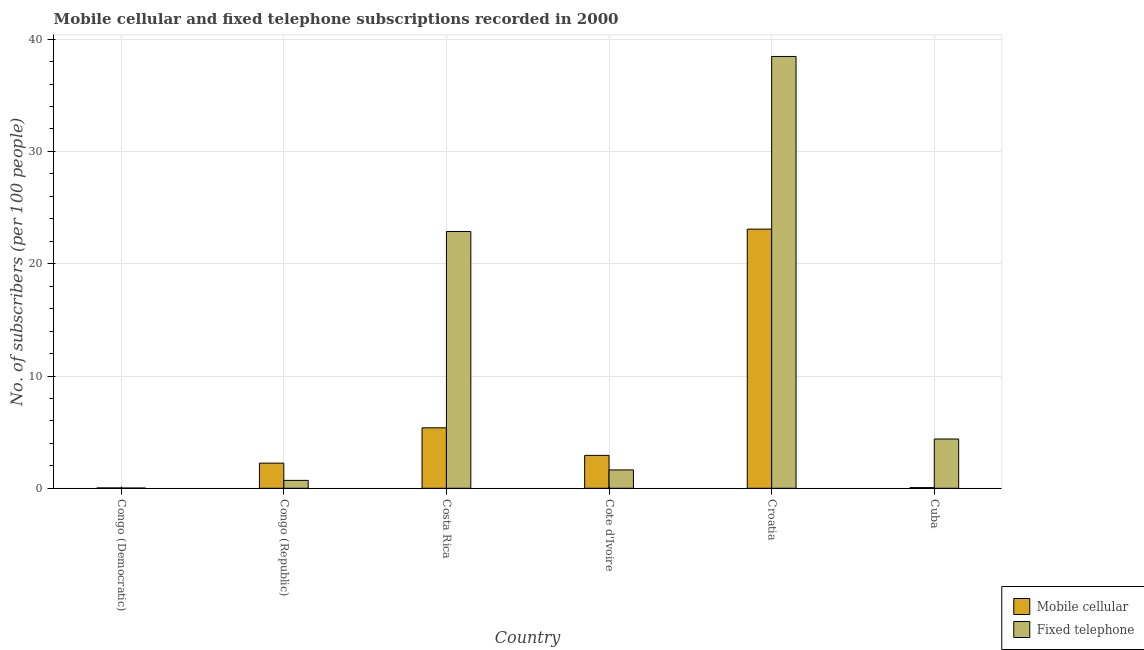Are the number of bars per tick equal to the number of legend labels?
Keep it short and to the point. Yes. How many bars are there on the 1st tick from the left?
Your response must be concise. 2. What is the label of the 1st group of bars from the left?
Your answer should be compact. Congo (Democratic). What is the number of fixed telephone subscribers in Congo (Republic)?
Keep it short and to the point. 0.7. Across all countries, what is the maximum number of fixed telephone subscribers?
Your answer should be compact. 38.46. Across all countries, what is the minimum number of mobile cellular subscribers?
Offer a terse response. 0.03. In which country was the number of mobile cellular subscribers maximum?
Your response must be concise. Croatia. In which country was the number of fixed telephone subscribers minimum?
Your answer should be very brief. Congo (Democratic). What is the total number of mobile cellular subscribers in the graph?
Provide a succinct answer. 33.73. What is the difference between the number of fixed telephone subscribers in Congo (Republic) and that in Croatia?
Ensure brevity in your answer.  -37.76. What is the difference between the number of mobile cellular subscribers in Costa Rica and the number of fixed telephone subscribers in Cote d'Ivoire?
Give a very brief answer. 3.75. What is the average number of mobile cellular subscribers per country?
Make the answer very short. 5.62. What is the difference between the number of mobile cellular subscribers and number of fixed telephone subscribers in Congo (Democratic)?
Keep it short and to the point. 0.01. In how many countries, is the number of fixed telephone subscribers greater than 10 ?
Your answer should be very brief. 2. What is the ratio of the number of mobile cellular subscribers in Congo (Democratic) to that in Cuba?
Your answer should be compact. 0.54. Is the difference between the number of mobile cellular subscribers in Costa Rica and Cuba greater than the difference between the number of fixed telephone subscribers in Costa Rica and Cuba?
Offer a very short reply. No. What is the difference between the highest and the second highest number of mobile cellular subscribers?
Give a very brief answer. 17.7. What is the difference between the highest and the lowest number of mobile cellular subscribers?
Provide a succinct answer. 23.05. What does the 1st bar from the left in Cote d'Ivoire represents?
Give a very brief answer. Mobile cellular. What does the 1st bar from the right in Croatia represents?
Make the answer very short. Fixed telephone. What is the difference between two consecutive major ticks on the Y-axis?
Offer a very short reply. 10. Are the values on the major ticks of Y-axis written in scientific E-notation?
Your response must be concise. No. Does the graph contain any zero values?
Your answer should be compact. No. Where does the legend appear in the graph?
Keep it short and to the point. Bottom right. How many legend labels are there?
Make the answer very short. 2. What is the title of the graph?
Your answer should be compact. Mobile cellular and fixed telephone subscriptions recorded in 2000. Does "Lower secondary rate" appear as one of the legend labels in the graph?
Offer a terse response. No. What is the label or title of the X-axis?
Your answer should be compact. Country. What is the label or title of the Y-axis?
Ensure brevity in your answer.  No. of subscribers (per 100 people). What is the No. of subscribers (per 100 people) of Mobile cellular in Congo (Democratic)?
Your answer should be compact. 0.03. What is the No. of subscribers (per 100 people) of Fixed telephone in Congo (Democratic)?
Provide a short and direct response. 0.02. What is the No. of subscribers (per 100 people) of Mobile cellular in Congo (Republic)?
Provide a short and direct response. 2.24. What is the No. of subscribers (per 100 people) in Fixed telephone in Congo (Republic)?
Your response must be concise. 0.7. What is the No. of subscribers (per 100 people) of Mobile cellular in Costa Rica?
Your answer should be very brief. 5.39. What is the No. of subscribers (per 100 people) in Fixed telephone in Costa Rica?
Your response must be concise. 22.87. What is the No. of subscribers (per 100 people) of Mobile cellular in Cote d'Ivoire?
Make the answer very short. 2.93. What is the No. of subscribers (per 100 people) in Fixed telephone in Cote d'Ivoire?
Make the answer very short. 1.63. What is the No. of subscribers (per 100 people) of Mobile cellular in Croatia?
Your answer should be compact. 23.08. What is the No. of subscribers (per 100 people) of Fixed telephone in Croatia?
Offer a very short reply. 38.46. What is the No. of subscribers (per 100 people) of Mobile cellular in Cuba?
Make the answer very short. 0.06. What is the No. of subscribers (per 100 people) of Fixed telephone in Cuba?
Your answer should be compact. 4.39. Across all countries, what is the maximum No. of subscribers (per 100 people) of Mobile cellular?
Your answer should be compact. 23.08. Across all countries, what is the maximum No. of subscribers (per 100 people) in Fixed telephone?
Keep it short and to the point. 38.46. Across all countries, what is the minimum No. of subscribers (per 100 people) in Mobile cellular?
Your answer should be very brief. 0.03. Across all countries, what is the minimum No. of subscribers (per 100 people) of Fixed telephone?
Offer a very short reply. 0.02. What is the total No. of subscribers (per 100 people) in Mobile cellular in the graph?
Your response must be concise. 33.73. What is the total No. of subscribers (per 100 people) in Fixed telephone in the graph?
Keep it short and to the point. 68.08. What is the difference between the No. of subscribers (per 100 people) in Mobile cellular in Congo (Democratic) and that in Congo (Republic)?
Your answer should be compact. -2.21. What is the difference between the No. of subscribers (per 100 people) of Fixed telephone in Congo (Democratic) and that in Congo (Republic)?
Provide a short and direct response. -0.68. What is the difference between the No. of subscribers (per 100 people) in Mobile cellular in Congo (Democratic) and that in Costa Rica?
Ensure brevity in your answer.  -5.35. What is the difference between the No. of subscribers (per 100 people) in Fixed telephone in Congo (Democratic) and that in Costa Rica?
Offer a terse response. -22.85. What is the difference between the No. of subscribers (per 100 people) of Mobile cellular in Congo (Democratic) and that in Cote d'Ivoire?
Give a very brief answer. -2.9. What is the difference between the No. of subscribers (per 100 people) of Fixed telephone in Congo (Democratic) and that in Cote d'Ivoire?
Your response must be concise. -1.61. What is the difference between the No. of subscribers (per 100 people) in Mobile cellular in Congo (Democratic) and that in Croatia?
Provide a short and direct response. -23.05. What is the difference between the No. of subscribers (per 100 people) of Fixed telephone in Congo (Democratic) and that in Croatia?
Make the answer very short. -38.44. What is the difference between the No. of subscribers (per 100 people) of Mobile cellular in Congo (Democratic) and that in Cuba?
Make the answer very short. -0.03. What is the difference between the No. of subscribers (per 100 people) of Fixed telephone in Congo (Democratic) and that in Cuba?
Your answer should be compact. -4.37. What is the difference between the No. of subscribers (per 100 people) of Mobile cellular in Congo (Republic) and that in Costa Rica?
Offer a terse response. -3.15. What is the difference between the No. of subscribers (per 100 people) in Fixed telephone in Congo (Republic) and that in Costa Rica?
Your answer should be compact. -22.17. What is the difference between the No. of subscribers (per 100 people) of Mobile cellular in Congo (Republic) and that in Cote d'Ivoire?
Provide a succinct answer. -0.69. What is the difference between the No. of subscribers (per 100 people) in Fixed telephone in Congo (Republic) and that in Cote d'Ivoire?
Offer a terse response. -0.93. What is the difference between the No. of subscribers (per 100 people) in Mobile cellular in Congo (Republic) and that in Croatia?
Make the answer very short. -20.84. What is the difference between the No. of subscribers (per 100 people) of Fixed telephone in Congo (Republic) and that in Croatia?
Provide a succinct answer. -37.76. What is the difference between the No. of subscribers (per 100 people) of Mobile cellular in Congo (Republic) and that in Cuba?
Offer a very short reply. 2.18. What is the difference between the No. of subscribers (per 100 people) of Fixed telephone in Congo (Republic) and that in Cuba?
Make the answer very short. -3.68. What is the difference between the No. of subscribers (per 100 people) of Mobile cellular in Costa Rica and that in Cote d'Ivoire?
Make the answer very short. 2.45. What is the difference between the No. of subscribers (per 100 people) of Fixed telephone in Costa Rica and that in Cote d'Ivoire?
Provide a succinct answer. 21.24. What is the difference between the No. of subscribers (per 100 people) in Mobile cellular in Costa Rica and that in Croatia?
Your answer should be very brief. -17.7. What is the difference between the No. of subscribers (per 100 people) in Fixed telephone in Costa Rica and that in Croatia?
Your response must be concise. -15.59. What is the difference between the No. of subscribers (per 100 people) in Mobile cellular in Costa Rica and that in Cuba?
Provide a short and direct response. 5.33. What is the difference between the No. of subscribers (per 100 people) in Fixed telephone in Costa Rica and that in Cuba?
Offer a terse response. 18.48. What is the difference between the No. of subscribers (per 100 people) in Mobile cellular in Cote d'Ivoire and that in Croatia?
Your response must be concise. -20.15. What is the difference between the No. of subscribers (per 100 people) of Fixed telephone in Cote d'Ivoire and that in Croatia?
Your response must be concise. -36.83. What is the difference between the No. of subscribers (per 100 people) of Mobile cellular in Cote d'Ivoire and that in Cuba?
Keep it short and to the point. 2.87. What is the difference between the No. of subscribers (per 100 people) of Fixed telephone in Cote d'Ivoire and that in Cuba?
Make the answer very short. -2.75. What is the difference between the No. of subscribers (per 100 people) of Mobile cellular in Croatia and that in Cuba?
Your answer should be compact. 23.02. What is the difference between the No. of subscribers (per 100 people) of Fixed telephone in Croatia and that in Cuba?
Your answer should be very brief. 34.07. What is the difference between the No. of subscribers (per 100 people) of Mobile cellular in Congo (Democratic) and the No. of subscribers (per 100 people) of Fixed telephone in Congo (Republic)?
Make the answer very short. -0.67. What is the difference between the No. of subscribers (per 100 people) of Mobile cellular in Congo (Democratic) and the No. of subscribers (per 100 people) of Fixed telephone in Costa Rica?
Your answer should be very brief. -22.84. What is the difference between the No. of subscribers (per 100 people) of Mobile cellular in Congo (Democratic) and the No. of subscribers (per 100 people) of Fixed telephone in Cote d'Ivoire?
Ensure brevity in your answer.  -1.6. What is the difference between the No. of subscribers (per 100 people) in Mobile cellular in Congo (Democratic) and the No. of subscribers (per 100 people) in Fixed telephone in Croatia?
Give a very brief answer. -38.43. What is the difference between the No. of subscribers (per 100 people) of Mobile cellular in Congo (Democratic) and the No. of subscribers (per 100 people) of Fixed telephone in Cuba?
Provide a short and direct response. -4.35. What is the difference between the No. of subscribers (per 100 people) of Mobile cellular in Congo (Republic) and the No. of subscribers (per 100 people) of Fixed telephone in Costa Rica?
Make the answer very short. -20.63. What is the difference between the No. of subscribers (per 100 people) in Mobile cellular in Congo (Republic) and the No. of subscribers (per 100 people) in Fixed telephone in Cote d'Ivoire?
Your answer should be very brief. 0.6. What is the difference between the No. of subscribers (per 100 people) in Mobile cellular in Congo (Republic) and the No. of subscribers (per 100 people) in Fixed telephone in Croatia?
Your answer should be very brief. -36.22. What is the difference between the No. of subscribers (per 100 people) of Mobile cellular in Congo (Republic) and the No. of subscribers (per 100 people) of Fixed telephone in Cuba?
Make the answer very short. -2.15. What is the difference between the No. of subscribers (per 100 people) of Mobile cellular in Costa Rica and the No. of subscribers (per 100 people) of Fixed telephone in Cote d'Ivoire?
Your answer should be compact. 3.75. What is the difference between the No. of subscribers (per 100 people) in Mobile cellular in Costa Rica and the No. of subscribers (per 100 people) in Fixed telephone in Croatia?
Offer a very short reply. -33.07. What is the difference between the No. of subscribers (per 100 people) in Mobile cellular in Cote d'Ivoire and the No. of subscribers (per 100 people) in Fixed telephone in Croatia?
Provide a short and direct response. -35.53. What is the difference between the No. of subscribers (per 100 people) in Mobile cellular in Cote d'Ivoire and the No. of subscribers (per 100 people) in Fixed telephone in Cuba?
Your answer should be very brief. -1.45. What is the difference between the No. of subscribers (per 100 people) in Mobile cellular in Croatia and the No. of subscribers (per 100 people) in Fixed telephone in Cuba?
Make the answer very short. 18.7. What is the average No. of subscribers (per 100 people) in Mobile cellular per country?
Provide a succinct answer. 5.62. What is the average No. of subscribers (per 100 people) of Fixed telephone per country?
Provide a short and direct response. 11.35. What is the difference between the No. of subscribers (per 100 people) of Mobile cellular and No. of subscribers (per 100 people) of Fixed telephone in Congo (Democratic)?
Give a very brief answer. 0.01. What is the difference between the No. of subscribers (per 100 people) of Mobile cellular and No. of subscribers (per 100 people) of Fixed telephone in Congo (Republic)?
Ensure brevity in your answer.  1.54. What is the difference between the No. of subscribers (per 100 people) in Mobile cellular and No. of subscribers (per 100 people) in Fixed telephone in Costa Rica?
Provide a succinct answer. -17.49. What is the difference between the No. of subscribers (per 100 people) in Mobile cellular and No. of subscribers (per 100 people) in Fixed telephone in Cote d'Ivoire?
Your answer should be compact. 1.3. What is the difference between the No. of subscribers (per 100 people) in Mobile cellular and No. of subscribers (per 100 people) in Fixed telephone in Croatia?
Make the answer very short. -15.38. What is the difference between the No. of subscribers (per 100 people) in Mobile cellular and No. of subscribers (per 100 people) in Fixed telephone in Cuba?
Make the answer very short. -4.33. What is the ratio of the No. of subscribers (per 100 people) of Mobile cellular in Congo (Democratic) to that in Congo (Republic)?
Your answer should be compact. 0.01. What is the ratio of the No. of subscribers (per 100 people) in Fixed telephone in Congo (Democratic) to that in Congo (Republic)?
Provide a short and direct response. 0.03. What is the ratio of the No. of subscribers (per 100 people) of Mobile cellular in Congo (Democratic) to that in Costa Rica?
Provide a succinct answer. 0.01. What is the ratio of the No. of subscribers (per 100 people) in Fixed telephone in Congo (Democratic) to that in Costa Rica?
Offer a terse response. 0. What is the ratio of the No. of subscribers (per 100 people) in Mobile cellular in Congo (Democratic) to that in Cote d'Ivoire?
Offer a terse response. 0.01. What is the ratio of the No. of subscribers (per 100 people) of Fixed telephone in Congo (Democratic) to that in Cote d'Ivoire?
Ensure brevity in your answer.  0.01. What is the ratio of the No. of subscribers (per 100 people) of Mobile cellular in Congo (Democratic) to that in Croatia?
Make the answer very short. 0. What is the ratio of the No. of subscribers (per 100 people) in Mobile cellular in Congo (Democratic) to that in Cuba?
Give a very brief answer. 0.54. What is the ratio of the No. of subscribers (per 100 people) in Fixed telephone in Congo (Democratic) to that in Cuba?
Keep it short and to the point. 0. What is the ratio of the No. of subscribers (per 100 people) in Mobile cellular in Congo (Republic) to that in Costa Rica?
Your answer should be very brief. 0.42. What is the ratio of the No. of subscribers (per 100 people) in Fixed telephone in Congo (Republic) to that in Costa Rica?
Offer a terse response. 0.03. What is the ratio of the No. of subscribers (per 100 people) in Mobile cellular in Congo (Republic) to that in Cote d'Ivoire?
Provide a short and direct response. 0.76. What is the ratio of the No. of subscribers (per 100 people) of Fixed telephone in Congo (Republic) to that in Cote d'Ivoire?
Provide a short and direct response. 0.43. What is the ratio of the No. of subscribers (per 100 people) in Mobile cellular in Congo (Republic) to that in Croatia?
Keep it short and to the point. 0.1. What is the ratio of the No. of subscribers (per 100 people) in Fixed telephone in Congo (Republic) to that in Croatia?
Keep it short and to the point. 0.02. What is the ratio of the No. of subscribers (per 100 people) in Mobile cellular in Congo (Republic) to that in Cuba?
Give a very brief answer. 38.16. What is the ratio of the No. of subscribers (per 100 people) in Fixed telephone in Congo (Republic) to that in Cuba?
Give a very brief answer. 0.16. What is the ratio of the No. of subscribers (per 100 people) in Mobile cellular in Costa Rica to that in Cote d'Ivoire?
Provide a short and direct response. 1.84. What is the ratio of the No. of subscribers (per 100 people) of Fixed telephone in Costa Rica to that in Cote d'Ivoire?
Offer a very short reply. 13.99. What is the ratio of the No. of subscribers (per 100 people) in Mobile cellular in Costa Rica to that in Croatia?
Keep it short and to the point. 0.23. What is the ratio of the No. of subscribers (per 100 people) of Fixed telephone in Costa Rica to that in Croatia?
Offer a very short reply. 0.59. What is the ratio of the No. of subscribers (per 100 people) of Mobile cellular in Costa Rica to that in Cuba?
Keep it short and to the point. 91.77. What is the ratio of the No. of subscribers (per 100 people) in Fixed telephone in Costa Rica to that in Cuba?
Provide a succinct answer. 5.21. What is the ratio of the No. of subscribers (per 100 people) of Mobile cellular in Cote d'Ivoire to that in Croatia?
Keep it short and to the point. 0.13. What is the ratio of the No. of subscribers (per 100 people) in Fixed telephone in Cote d'Ivoire to that in Croatia?
Provide a succinct answer. 0.04. What is the ratio of the No. of subscribers (per 100 people) of Mobile cellular in Cote d'Ivoire to that in Cuba?
Offer a terse response. 49.96. What is the ratio of the No. of subscribers (per 100 people) in Fixed telephone in Cote d'Ivoire to that in Cuba?
Offer a terse response. 0.37. What is the ratio of the No. of subscribers (per 100 people) of Mobile cellular in Croatia to that in Cuba?
Give a very brief answer. 393.37. What is the ratio of the No. of subscribers (per 100 people) in Fixed telephone in Croatia to that in Cuba?
Your response must be concise. 8.77. What is the difference between the highest and the second highest No. of subscribers (per 100 people) in Mobile cellular?
Your answer should be compact. 17.7. What is the difference between the highest and the second highest No. of subscribers (per 100 people) of Fixed telephone?
Ensure brevity in your answer.  15.59. What is the difference between the highest and the lowest No. of subscribers (per 100 people) in Mobile cellular?
Keep it short and to the point. 23.05. What is the difference between the highest and the lowest No. of subscribers (per 100 people) of Fixed telephone?
Provide a short and direct response. 38.44. 